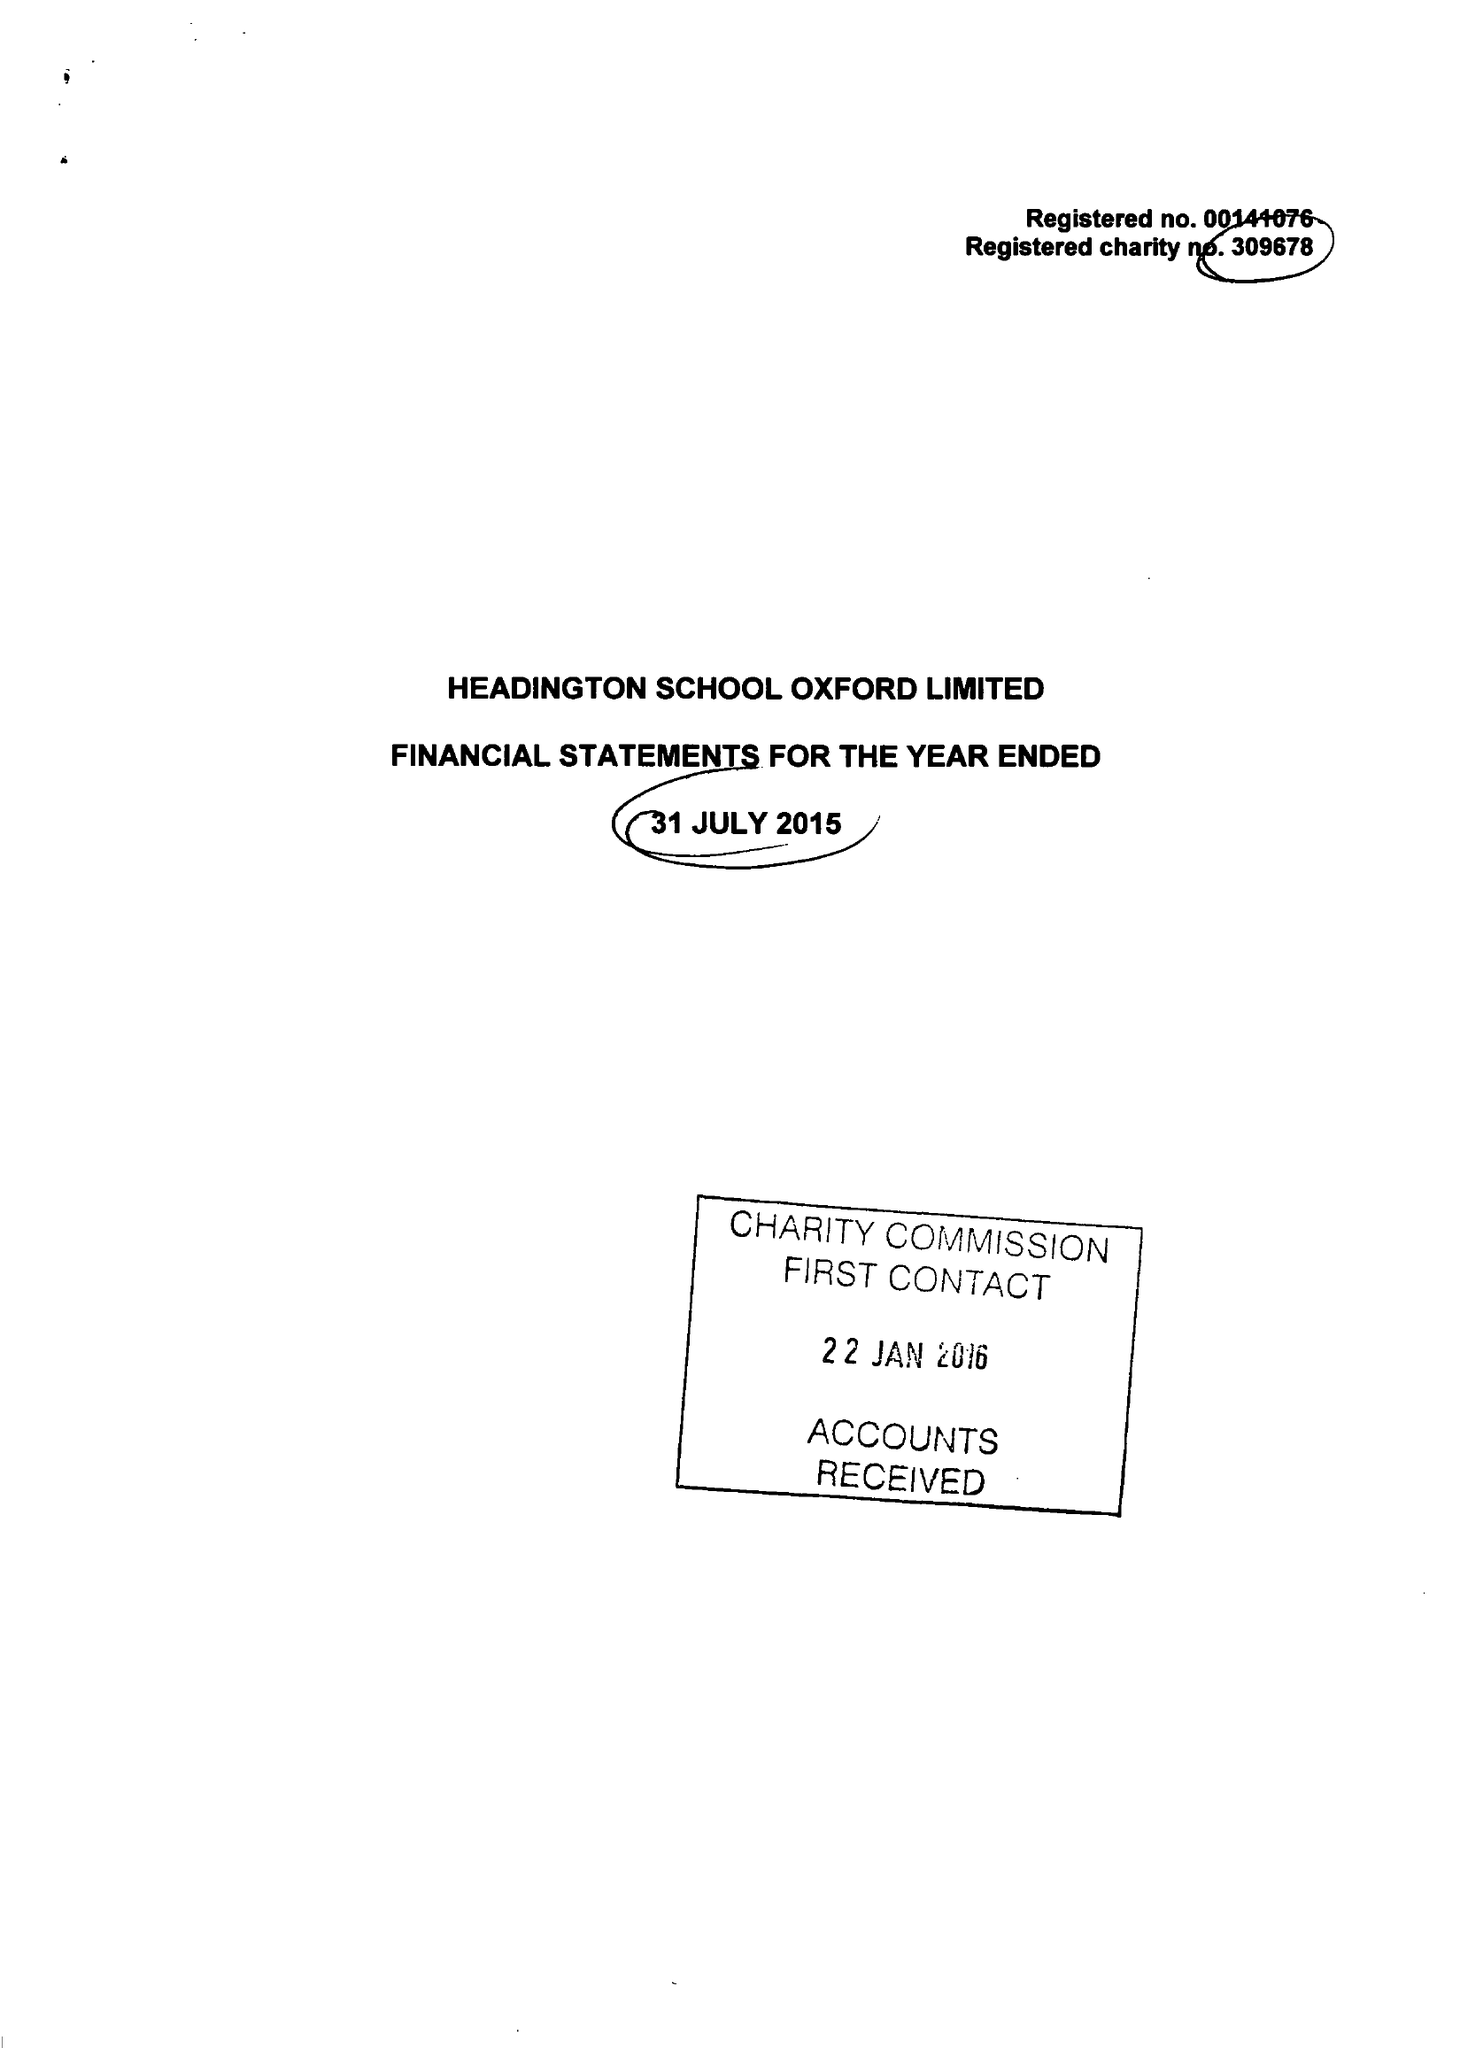What is the value for the charity_number?
Answer the question using a single word or phrase. 309678 